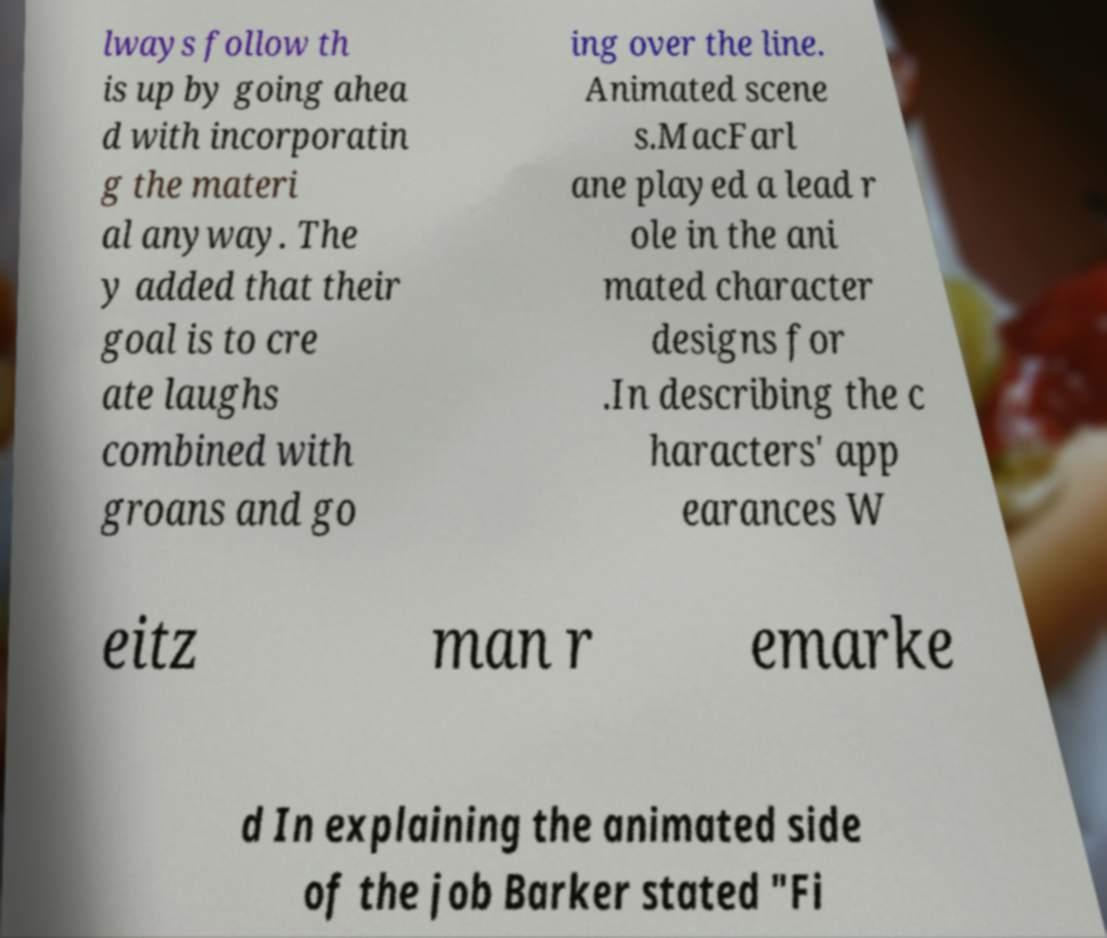Could you assist in decoding the text presented in this image and type it out clearly? lways follow th is up by going ahea d with incorporatin g the materi al anyway. The y added that their goal is to cre ate laughs combined with groans and go ing over the line. Animated scene s.MacFarl ane played a lead r ole in the ani mated character designs for .In describing the c haracters' app earances W eitz man r emarke d In explaining the animated side of the job Barker stated "Fi 